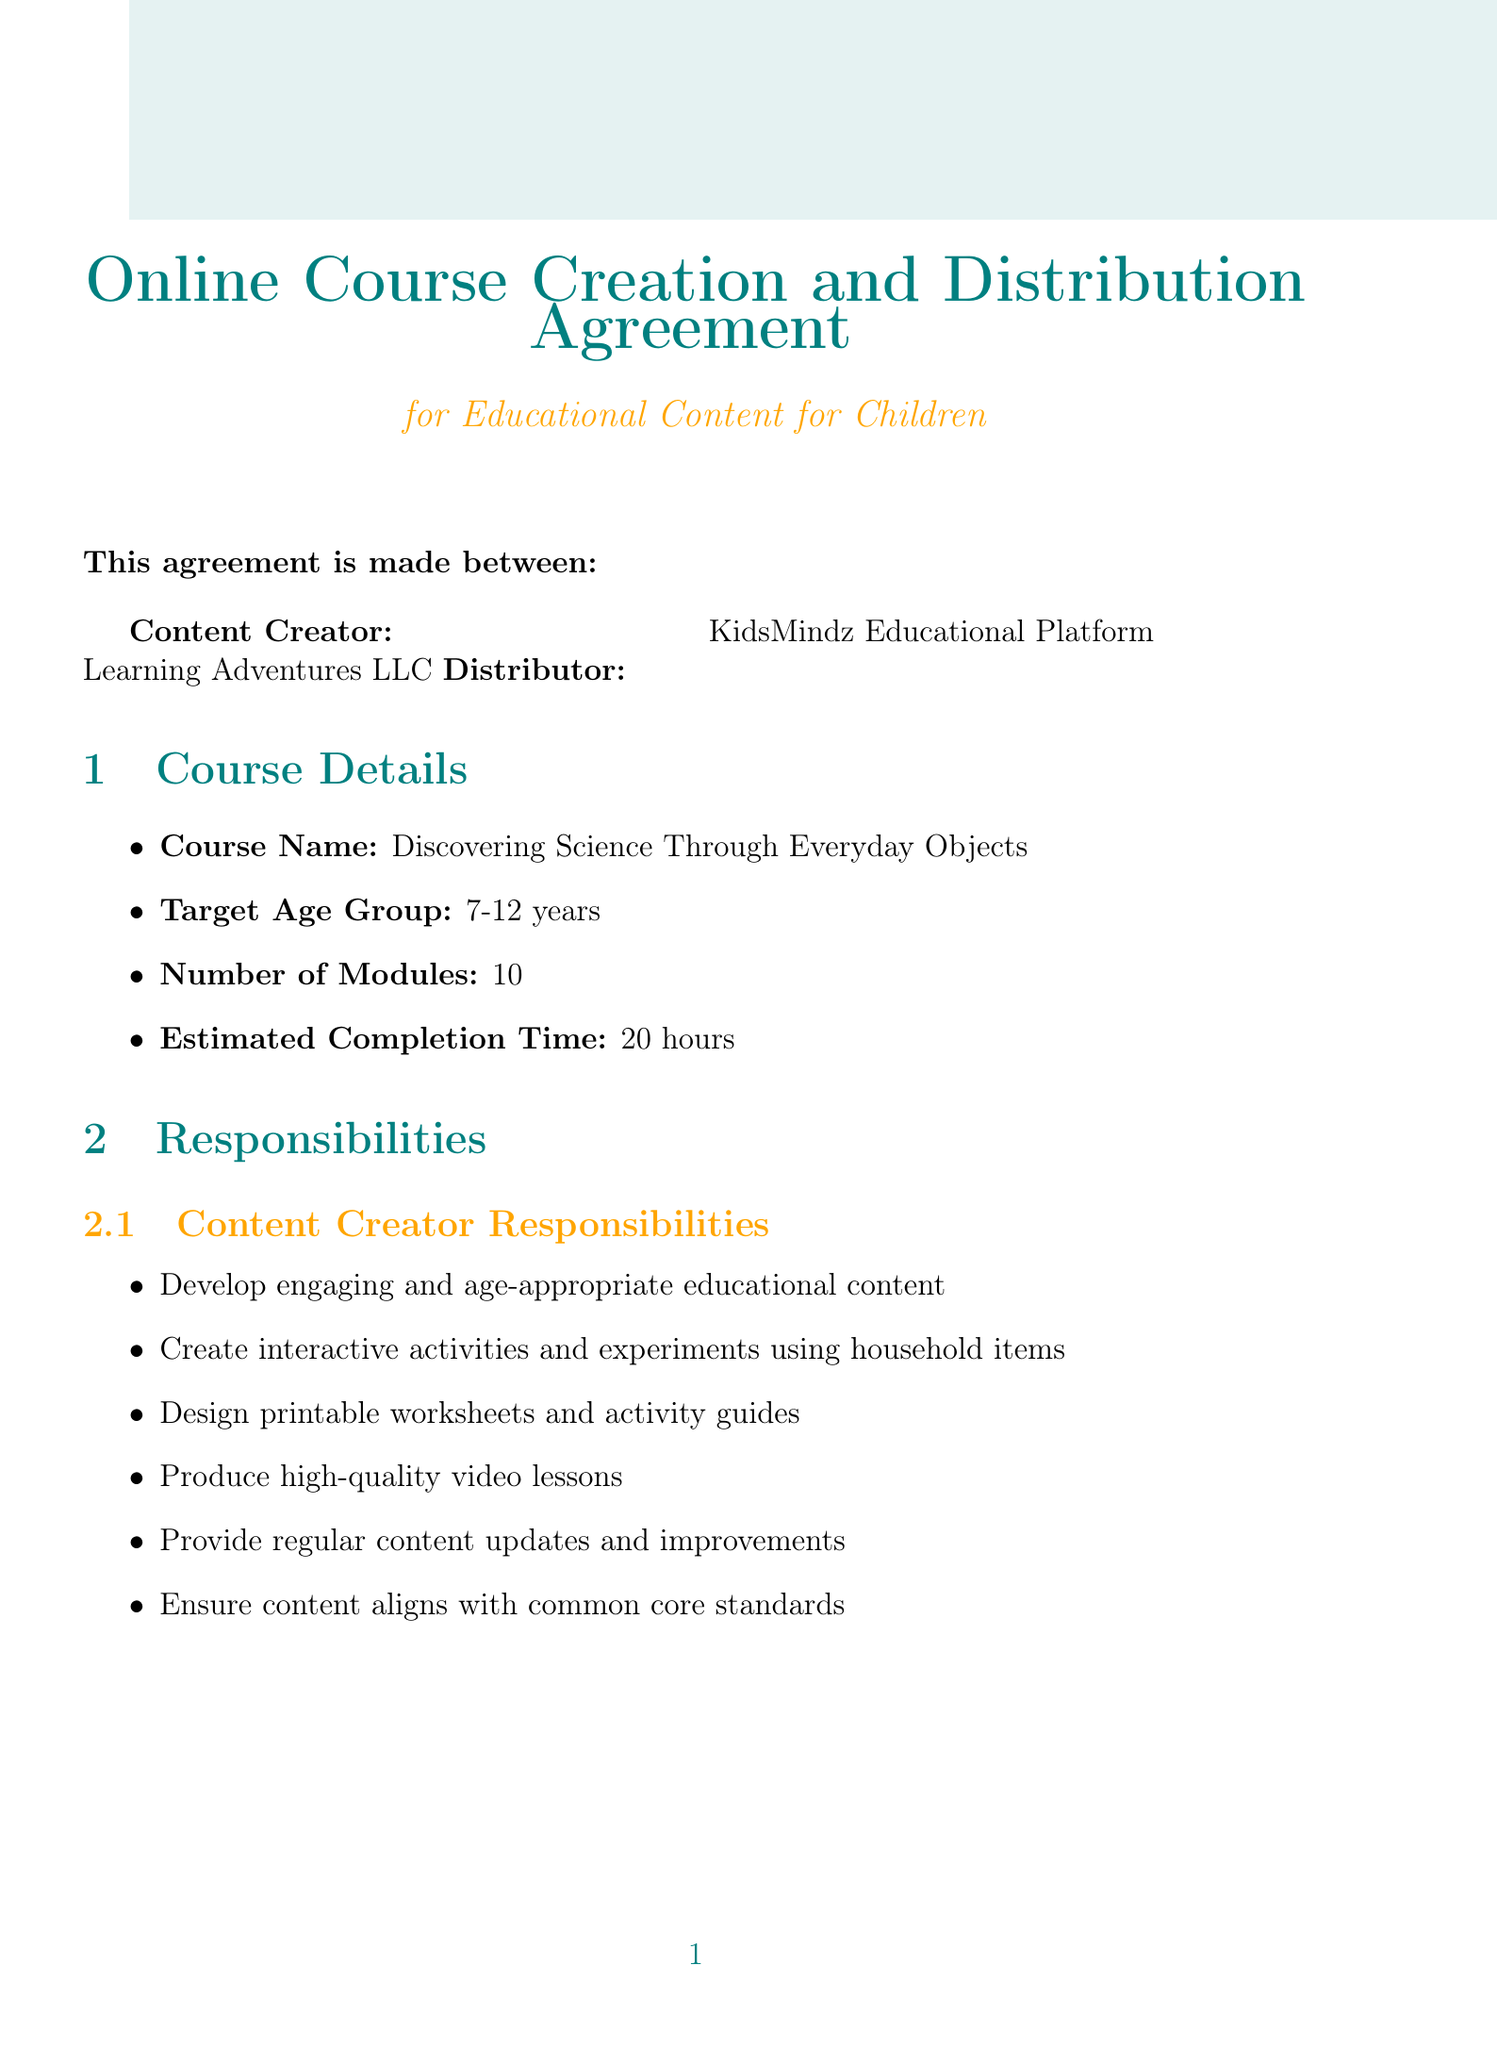What is the course name? The course name is explicitly stated in the course details section of the document.
Answer: Discovering Science Through Everyday Objects Who is the content creator? The content creator's name is listed at the beginning of the document under the parties section.
Answer: Learning Adventures LLC What is the target age group for the course? The target age group is mentioned under course details.
Answer: 7-12 years How many modules does the course include? The number of modules is specified in the course details section.
Answer: 10 What percentage of revenue does the content creator receive? The revenue sharing section outlines the percentage distribution for the content creator.
Answer: 70 How often will payments be made to the content creator? The payment schedule is detailed in the revenue sharing section.
Answer: Monthly What is the initial term of the agreement? The termination section states the initial term of the agreement.
Answer: 2 years What is required for termination of the agreement? The termination notice requirement is specified under the termination section.
Answer: 60 days written notice What must KidsMindz comply with regarding user data? The data collection responsibilities are detailed in the data privacy section.
Answer: COPPA and other relevant data protection laws 